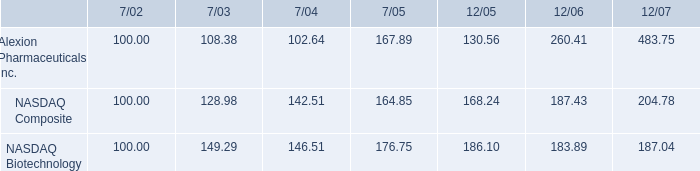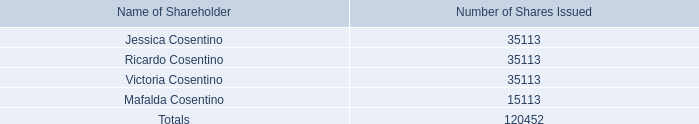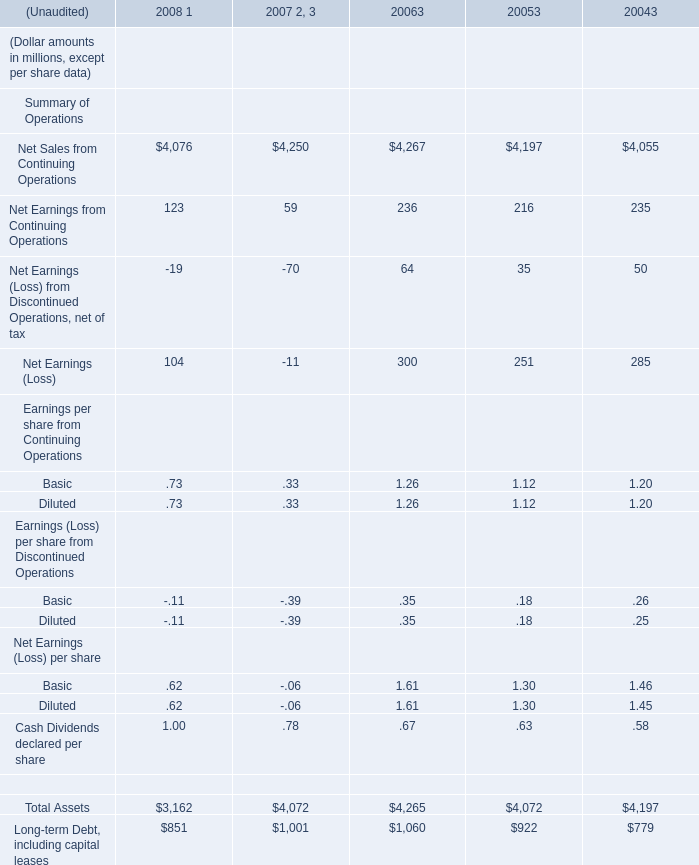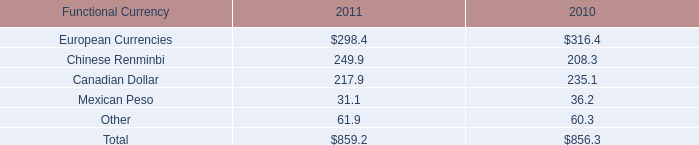what is the percent change in the investment into alexion pharmaceuticals between 7/02 and 7/03? 
Computations: ((108.38 - 100) / 100)
Answer: 0.0838. 